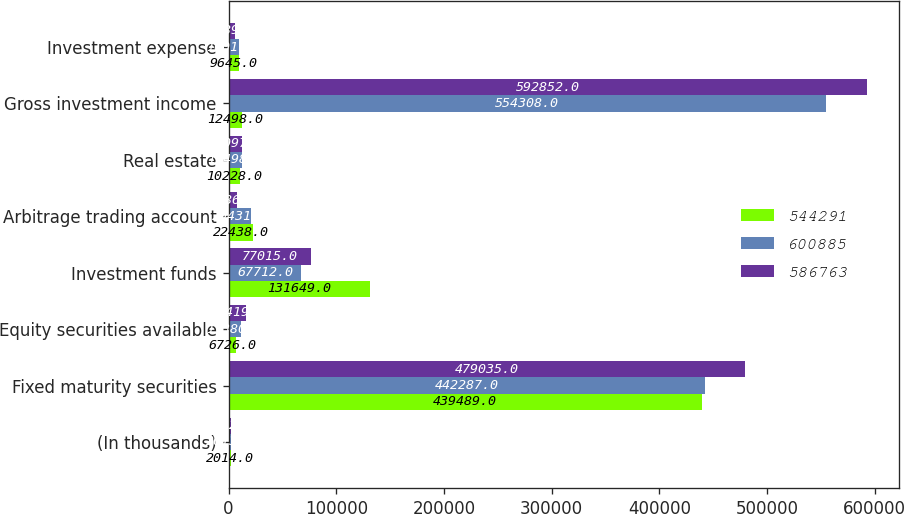<chart> <loc_0><loc_0><loc_500><loc_500><stacked_bar_chart><ecel><fcel>(In thousands)<fcel>Fixed maturity securities<fcel>Equity securities available<fcel>Investment funds<fcel>Arbitrage trading account<fcel>Real estate<fcel>Gross investment income<fcel>Investment expense<nl><fcel>544291<fcel>2014<fcel>439489<fcel>6726<fcel>131649<fcel>22438<fcel>10228<fcel>12498<fcel>9645<nl><fcel>600885<fcel>2013<fcel>442287<fcel>11380<fcel>67712<fcel>20431<fcel>12498<fcel>554308<fcel>10017<nl><fcel>586763<fcel>2012<fcel>479035<fcel>16419<fcel>77015<fcel>8286<fcel>12097<fcel>592852<fcel>6089<nl></chart> 